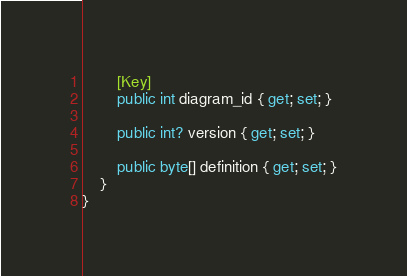<code> <loc_0><loc_0><loc_500><loc_500><_C#_>        [Key]
        public int diagram_id { get; set; }

        public int? version { get; set; }

        public byte[] definition { get; set; }
    }
}
</code> 